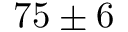Convert formula to latex. <formula><loc_0><loc_0><loc_500><loc_500>7 5 \pm 6</formula> 